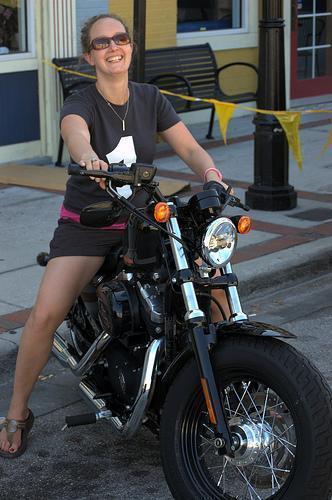How many motorcycles are there?
Give a very brief answer. 1. 